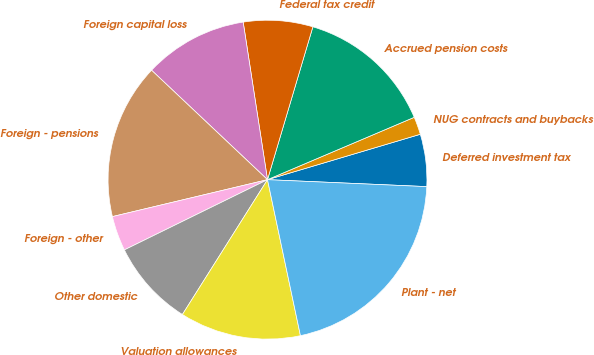<chart> <loc_0><loc_0><loc_500><loc_500><pie_chart><fcel>Deferred investment tax<fcel>NUG contracts and buybacks<fcel>Accrued pension costs<fcel>Federal tax credit<fcel>Foreign capital loss<fcel>Foreign - pensions<fcel>Foreign - other<fcel>Other domestic<fcel>Valuation allowances<fcel>Plant - net<nl><fcel>5.29%<fcel>1.8%<fcel>14.01%<fcel>7.03%<fcel>10.52%<fcel>15.76%<fcel>3.54%<fcel>8.78%<fcel>12.27%<fcel>20.99%<nl></chart> 